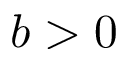Convert formula to latex. <formula><loc_0><loc_0><loc_500><loc_500>b > 0</formula> 